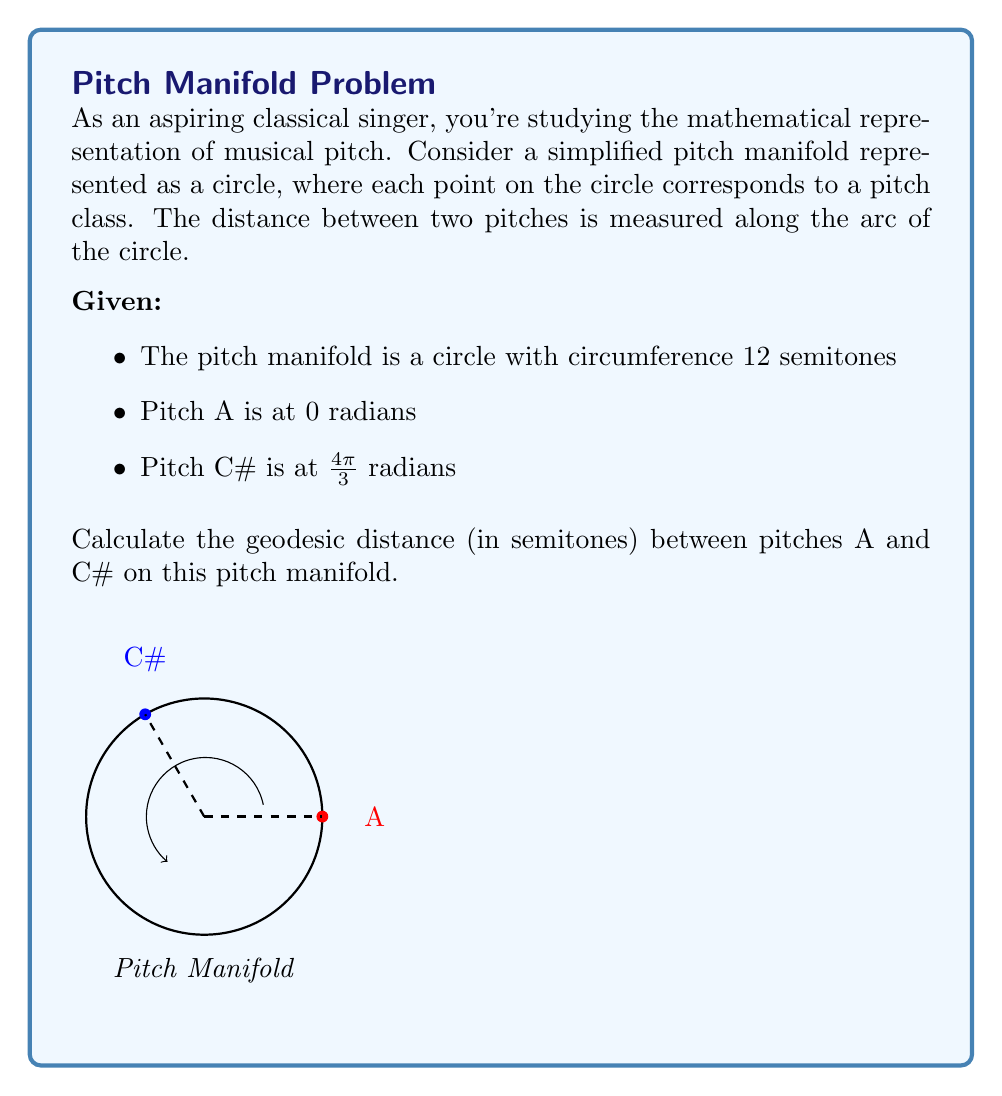Help me with this question. Let's approach this step-by-step:

1) In a circular pitch manifold, the geodesic distance is the shorter arc length between two points on the circle.

2) The total circumference of the circle represents 12 semitones. We can set up a proportion:

   $\frac{\text{arc length}}{2\pi r} = \frac{\text{semitones}}{12}$

3) We're given the angular positions of A (0 radians) and C# ($\frac{4\pi}{3}$ radians). The angular distance between them is:

   $\frac{4\pi}{3} - 0 = \frac{4\pi}{3}$ radians

4) However, we need to consider the shorter arc. The complement of this angle is:

   $2\pi - \frac{4\pi}{3} = \frac{2\pi}{3}$ radians

5) This shorter arc is our geodesic distance. Let's call this angle $\theta$:

   $\theta = \frac{2\pi}{3}$ radians

6) Now we can set up our proportion:

   $\frac{\theta}{2\pi} = \frac{\text{semitones}}{12}$

7) Solving for semitones:

   $\text{semitones} = \frac{12\theta}{2\pi} = \frac{12 \cdot \frac{2\pi}{3}}{2\pi} = 4$

Thus, the geodesic distance between A and C# on this pitch manifold is 4 semitones.
Answer: 4 semitones 